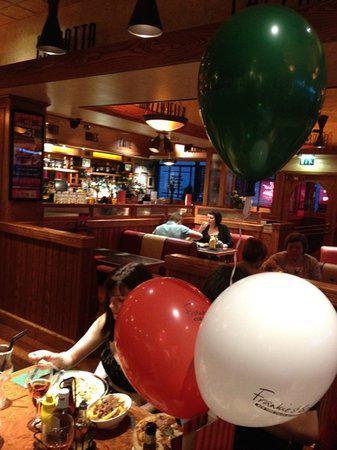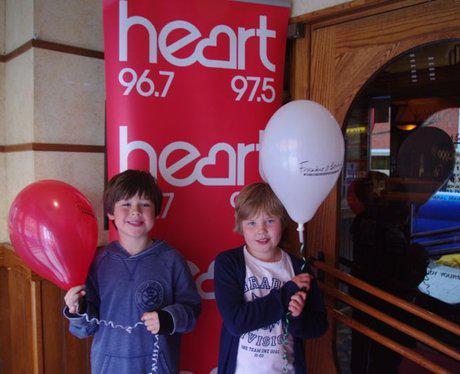The first image is the image on the left, the second image is the image on the right. Assess this claim about the two images: "The left and right image contains no more than six balloons.". Correct or not? Answer yes or no. Yes. The first image is the image on the left, the second image is the image on the right. Considering the images on both sides, is "The left image features no more than four balloons in a restaurant scene, including red and green balloons, and the right image includes a red balloon to the left of a white balloon." valid? Answer yes or no. Yes. 